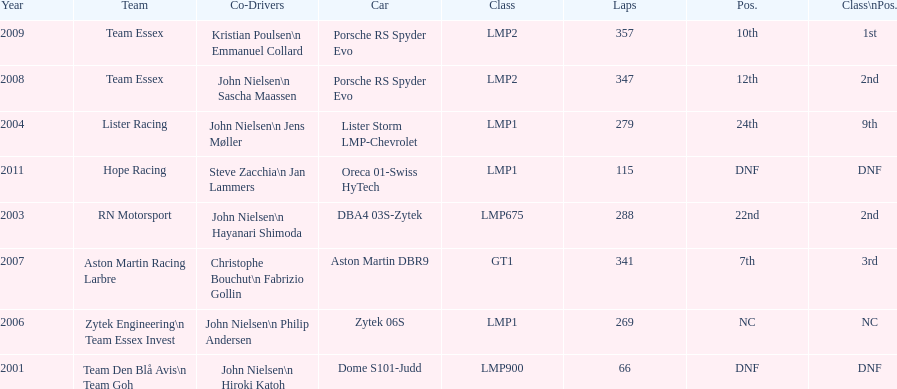How often was the final position greater than 20? 2. 